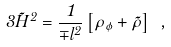<formula> <loc_0><loc_0><loc_500><loc_500>3 { \tilde { H } } ^ { 2 } = \frac { 1 } { \mp l ^ { 2 } } \left [ \rho _ { \phi } + { \tilde { \rho } } \right ] \ , \\</formula> 